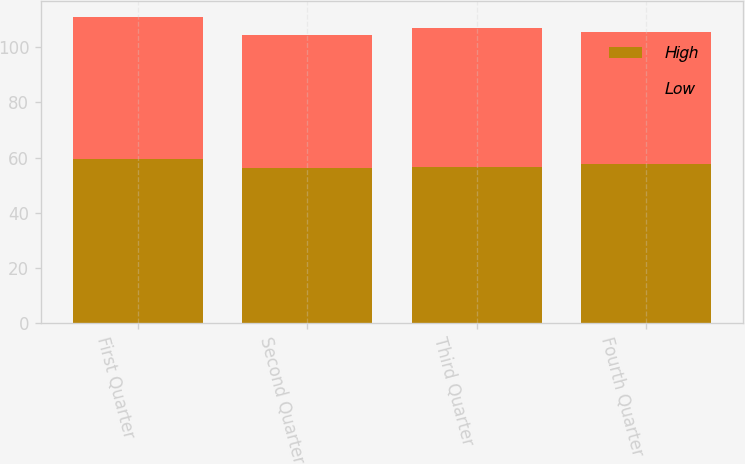<chart> <loc_0><loc_0><loc_500><loc_500><stacked_bar_chart><ecel><fcel>First Quarter<fcel>Second Quarter<fcel>Third Quarter<fcel>Fourth Quarter<nl><fcel>High<fcel>59.3<fcel>56.04<fcel>56.63<fcel>57.53<nl><fcel>Low<fcel>51.78<fcel>48.25<fcel>50.18<fcel>47.88<nl></chart> 